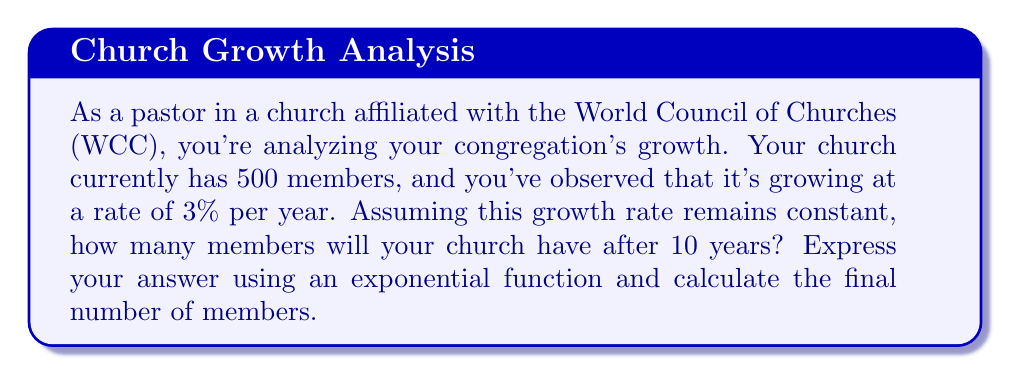Can you answer this question? To solve this problem, we'll use an exponential growth function. The general form of an exponential growth function is:

$$A(t) = A_0 \cdot (1 + r)^t$$

Where:
$A(t)$ is the amount after time $t$
$A_0$ is the initial amount
$r$ is the growth rate (as a decimal)
$t$ is the time period

Given:
$A_0 = 500$ (initial number of members)
$r = 0.03$ (3% growth rate expressed as a decimal)
$t = 10$ years

Let's substitute these values into our exponential growth function:

$$A(10) = 500 \cdot (1 + 0.03)^{10}$$

Now, let's calculate step by step:

1) First, calculate $(1 + 0.03)^{10}$:
   $$(1.03)^{10} \approx 1.3439$$

2) Now multiply this by the initial amount:
   $$500 \cdot 1.3439 \approx 671.95$$

Therefore, after 10 years, the church will have approximately 672 members (rounding to the nearest whole number).
Answer: The exponential function describing the church's growth is:
$$A(t) = 500 \cdot (1.03)^t$$
After 10 years, the church will have approximately 672 members. 